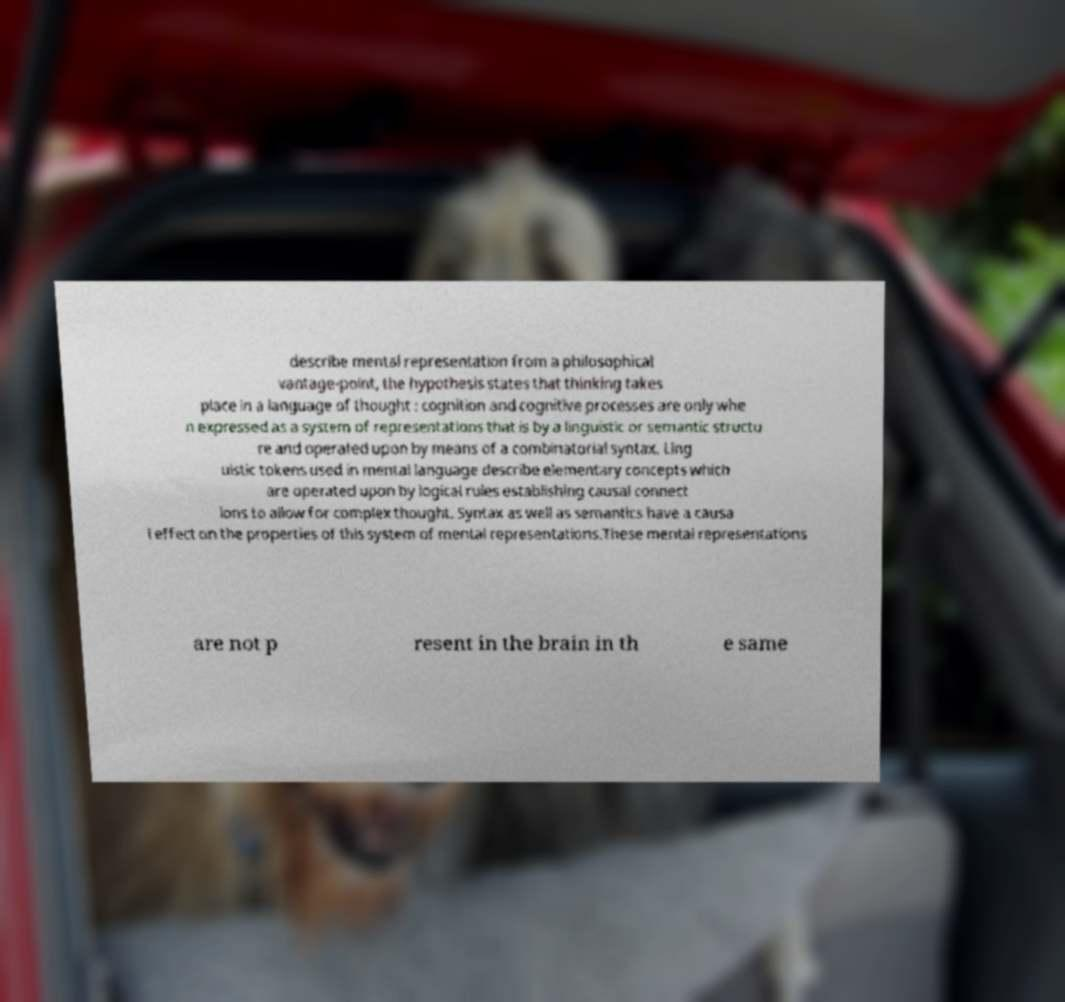Can you accurately transcribe the text from the provided image for me? describe mental representation from a philosophical vantage-point, the hypothesis states that thinking takes place in a language of thought : cognition and cognitive processes are only whe n expressed as a system of representations that is by a linguistic or semantic structu re and operated upon by means of a combinatorial syntax. Ling uistic tokens used in mental language describe elementary concepts which are operated upon by logical rules establishing causal connect ions to allow for complex thought. Syntax as well as semantics have a causa l effect on the properties of this system of mental representations.These mental representations are not p resent in the brain in th e same 